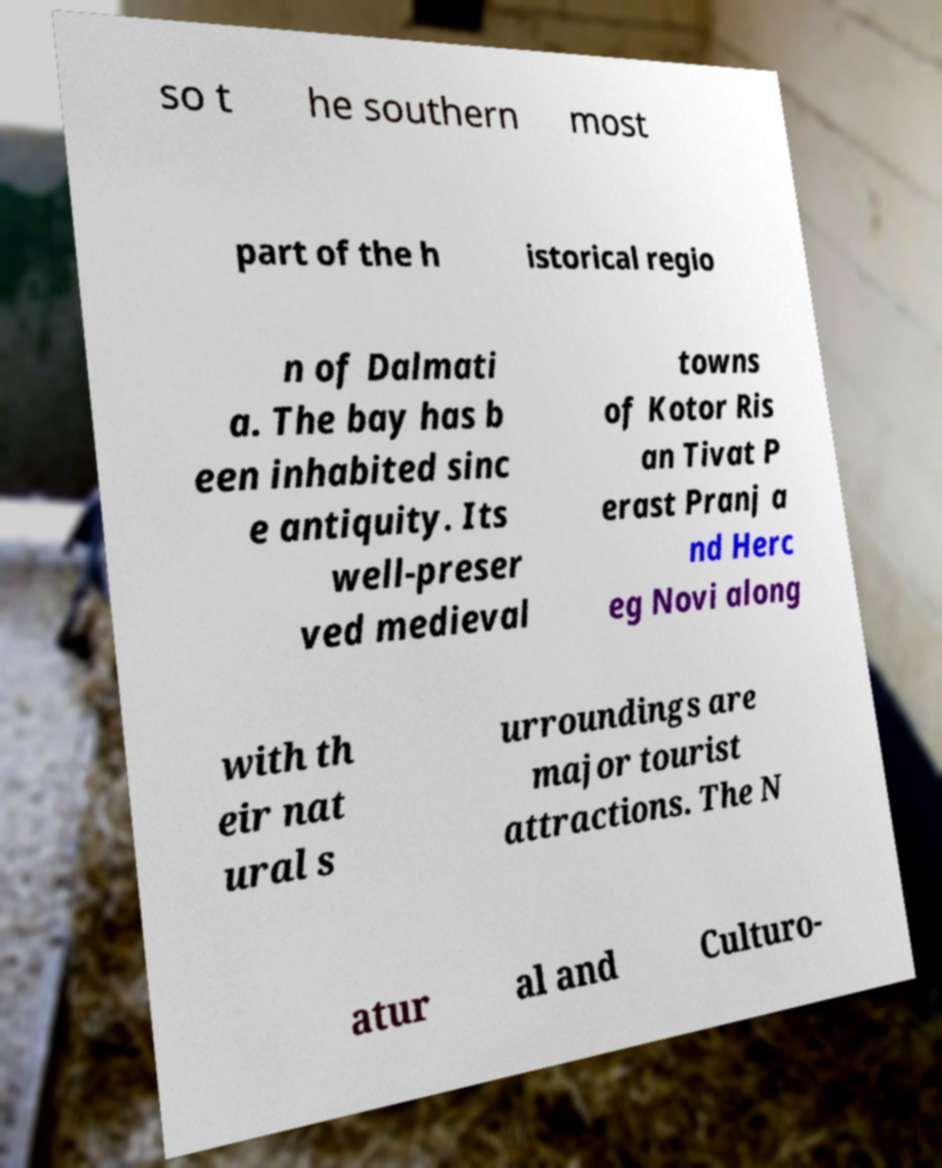I need the written content from this picture converted into text. Can you do that? so t he southern most part of the h istorical regio n of Dalmati a. The bay has b een inhabited sinc e antiquity. Its well-preser ved medieval towns of Kotor Ris an Tivat P erast Pranj a nd Herc eg Novi along with th eir nat ural s urroundings are major tourist attractions. The N atur al and Culturo- 